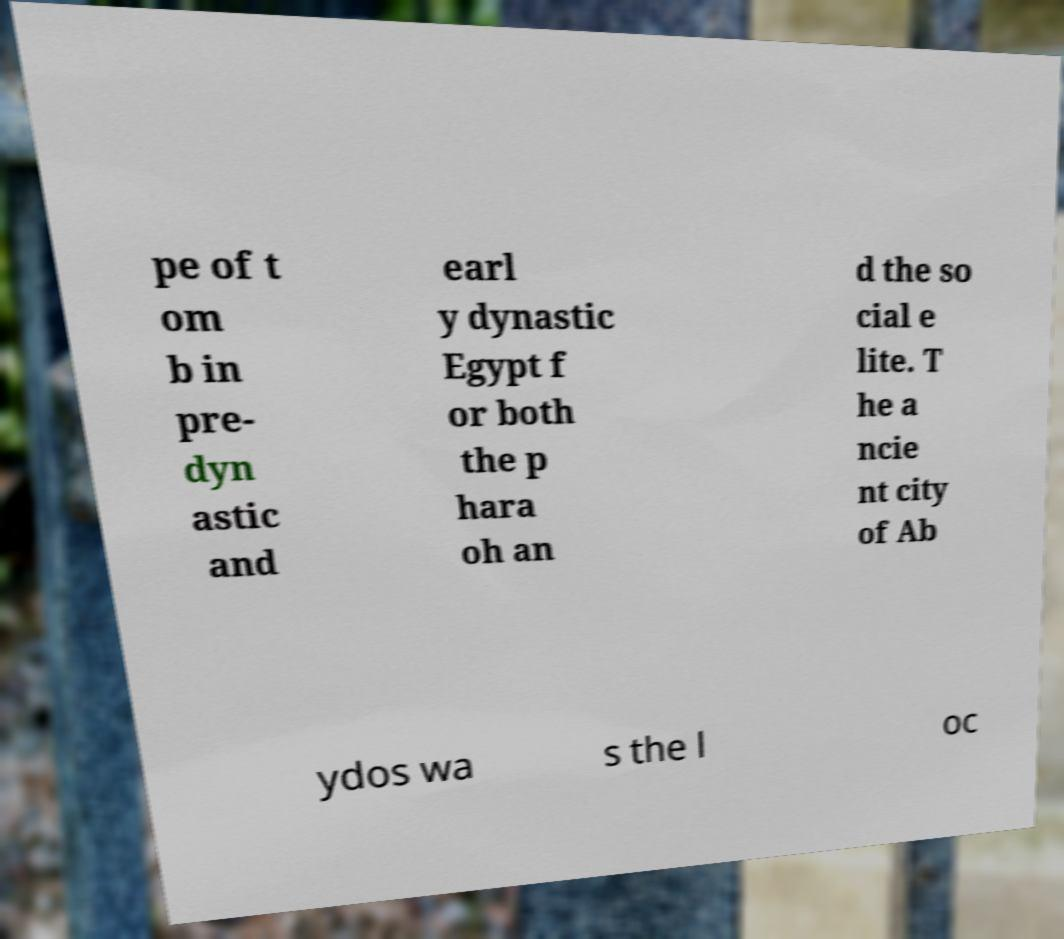Could you extract and type out the text from this image? pe of t om b in pre- dyn astic and earl y dynastic Egypt f or both the p hara oh an d the so cial e lite. T he a ncie nt city of Ab ydos wa s the l oc 